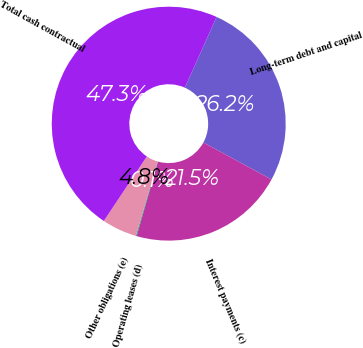<chart> <loc_0><loc_0><loc_500><loc_500><pie_chart><fcel>Long-term debt and capital<fcel>Interest payments (c)<fcel>Operating leases (d)<fcel>Other obligations (e)<fcel>Total cash contractual<nl><fcel>26.22%<fcel>21.5%<fcel>0.11%<fcel>4.83%<fcel>47.35%<nl></chart> 